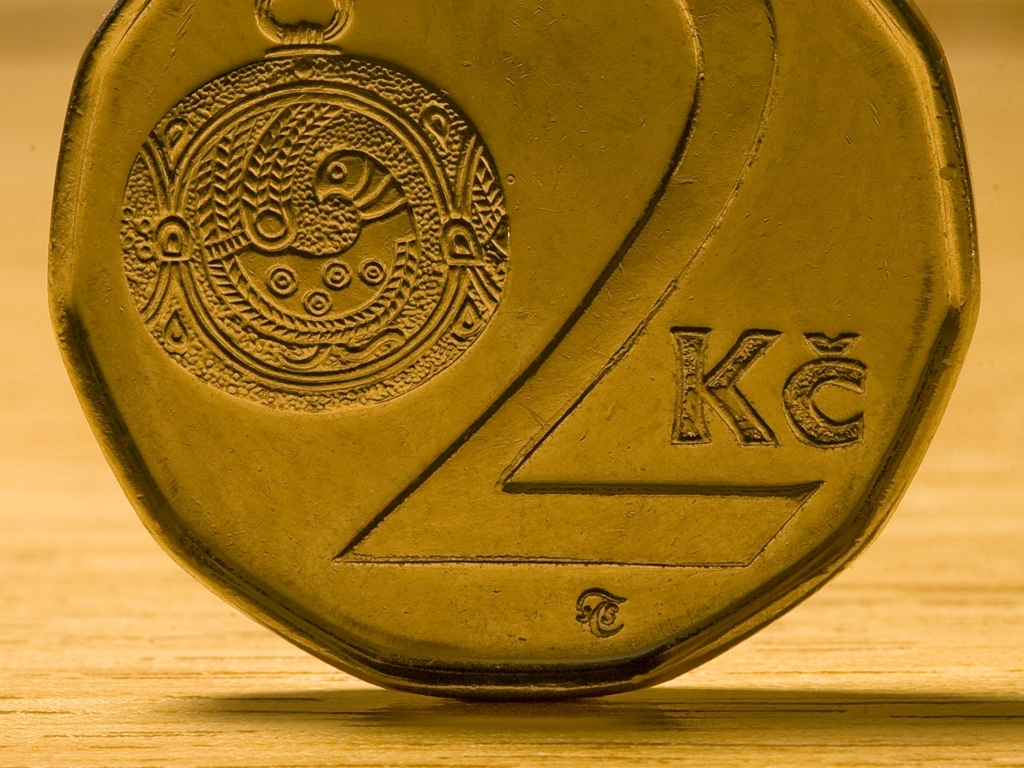What can you tell me about the coin in this image? The coin appears to be a collector's item or a token with intricate designs. It features an embossed image of a bird, possibly symbolizing freedom or a specific historical or cultural significance. The surrounding patterns have a tribal or ancient art feel, perhaps suggesting the coin's origin or the era it represents. What might the inscription 'KC' indicate? The 'KC' inscription could represent an abbreviation for a variety of things such as a place, an institution, a currency, or the initials of a person or an entity associated with the coin. Without additional context, it's difficult to determine the exact meaning, but it adds to the coin's uniqueness and may be a clue for identifying its origin or purpose. 